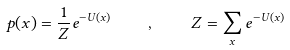Convert formula to latex. <formula><loc_0><loc_0><loc_500><loc_500>p ( { x } ) = \frac { 1 } { Z } e ^ { - U ( { x } ) } \quad , \quad Z = \sum _ { x } e ^ { - U ( { x } ) }</formula> 